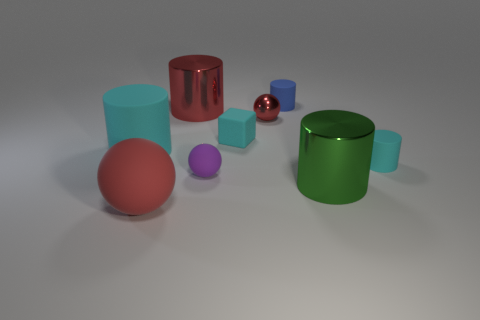What number of small things are yellow cylinders or green cylinders?
Ensure brevity in your answer.  0. Are there any other things of the same color as the metal sphere?
Ensure brevity in your answer.  Yes. There is a tiny purple thing that is the same material as the cyan block; what shape is it?
Make the answer very short. Sphere. How big is the red shiny thing that is left of the purple matte object?
Keep it short and to the point. Large. What is the shape of the green metallic object?
Your answer should be very brief. Cylinder. There is a red sphere in front of the small purple ball; does it have the same size as the cyan cylinder on the right side of the big cyan rubber cylinder?
Keep it short and to the point. No. How big is the cyan cylinder to the left of the tiny cylinder left of the small cyan cylinder on the right side of the big red matte thing?
Ensure brevity in your answer.  Large. There is a big red object on the right side of the red object that is in front of the red ball behind the red rubber object; what is its shape?
Provide a short and direct response. Cylinder. There is a large metal object to the left of the small blue cylinder; what shape is it?
Provide a succinct answer. Cylinder. Do the green object and the tiny cyan cube that is on the right side of the tiny purple ball have the same material?
Your answer should be compact. No. 